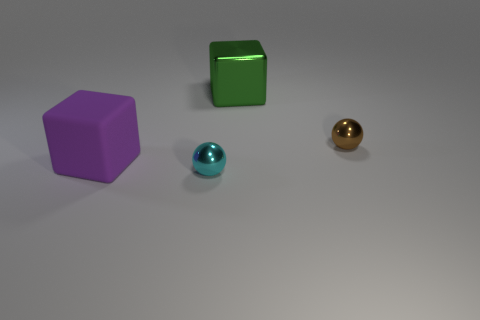Add 2 red metallic cubes. How many objects exist? 6 Subtract all cyan spheres. How many spheres are left? 1 Add 4 big green shiny blocks. How many big green shiny blocks are left? 5 Add 2 brown metallic spheres. How many brown metallic spheres exist? 3 Subtract 0 purple cylinders. How many objects are left? 4 Subtract all purple rubber cylinders. Subtract all brown metallic things. How many objects are left? 3 